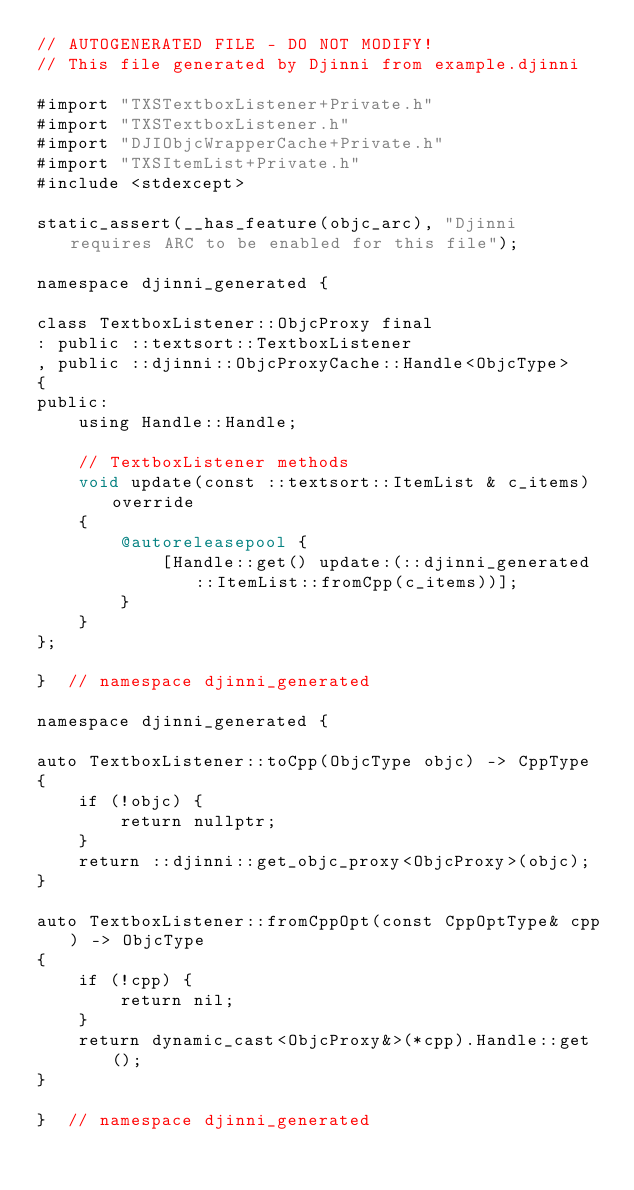Convert code to text. <code><loc_0><loc_0><loc_500><loc_500><_ObjectiveC_>// AUTOGENERATED FILE - DO NOT MODIFY!
// This file generated by Djinni from example.djinni

#import "TXSTextboxListener+Private.h"
#import "TXSTextboxListener.h"
#import "DJIObjcWrapperCache+Private.h"
#import "TXSItemList+Private.h"
#include <stdexcept>

static_assert(__has_feature(objc_arc), "Djinni requires ARC to be enabled for this file");

namespace djinni_generated {

class TextboxListener::ObjcProxy final
: public ::textsort::TextboxListener
, public ::djinni::ObjcProxyCache::Handle<ObjcType>
{
public:
    using Handle::Handle;

    // TextboxListener methods
    void update(const ::textsort::ItemList & c_items) override
    {
        @autoreleasepool {
            [Handle::get() update:(::djinni_generated::ItemList::fromCpp(c_items))];
        }
    }
};

}  // namespace djinni_generated

namespace djinni_generated {

auto TextboxListener::toCpp(ObjcType objc) -> CppType
{
    if (!objc) {
        return nullptr;
    }
    return ::djinni::get_objc_proxy<ObjcProxy>(objc);
}

auto TextboxListener::fromCppOpt(const CppOptType& cpp) -> ObjcType
{
    if (!cpp) {
        return nil;
    }
    return dynamic_cast<ObjcProxy&>(*cpp).Handle::get();
}

}  // namespace djinni_generated
</code> 